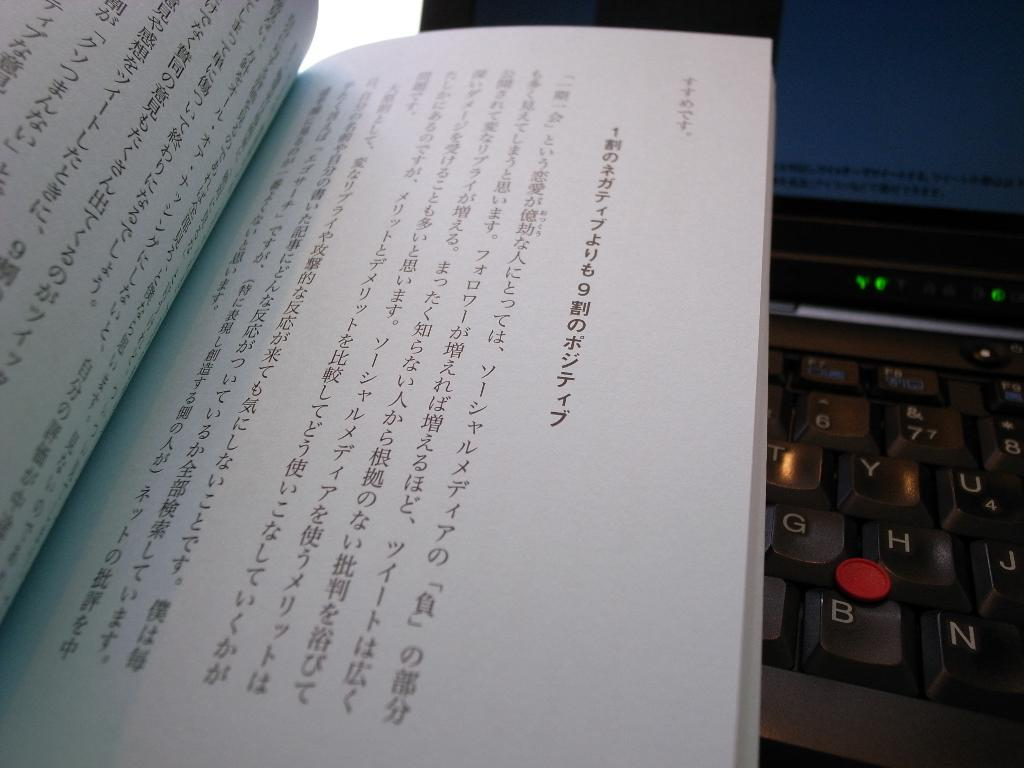<image>
Summarize the visual content of the image. a book in chinese is lying on a keyboard 